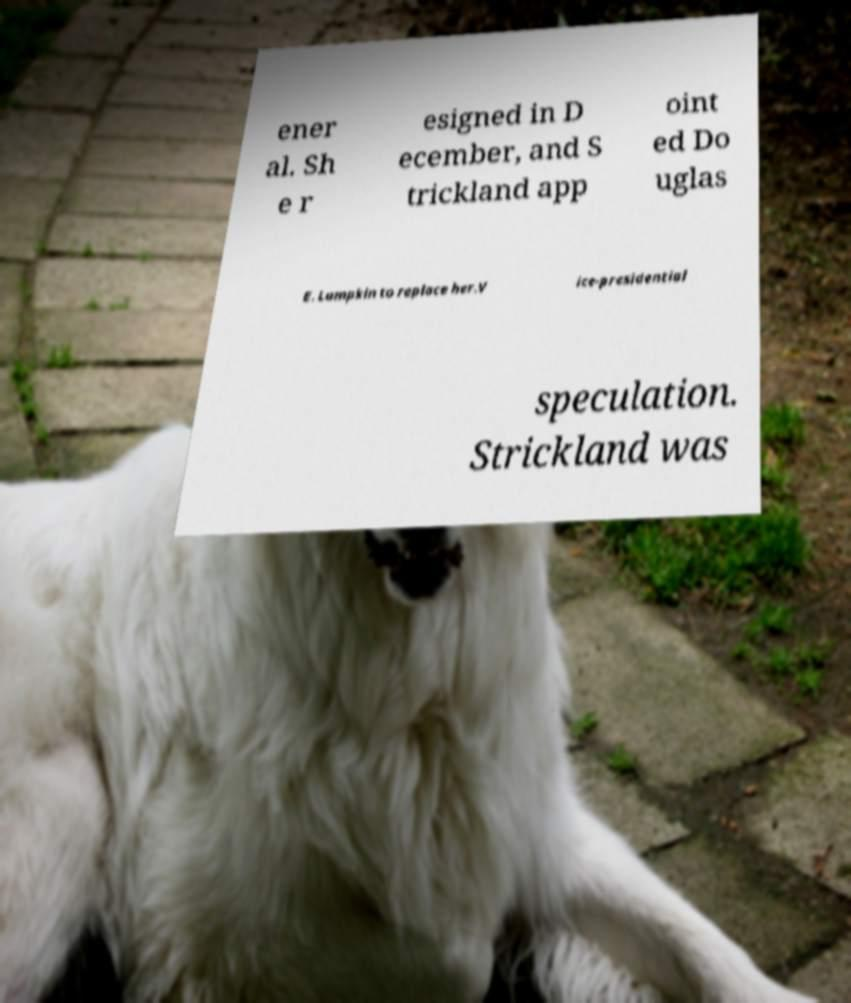Please read and relay the text visible in this image. What does it say? ener al. Sh e r esigned in D ecember, and S trickland app oint ed Do uglas E. Lumpkin to replace her.V ice-presidential speculation. Strickland was 